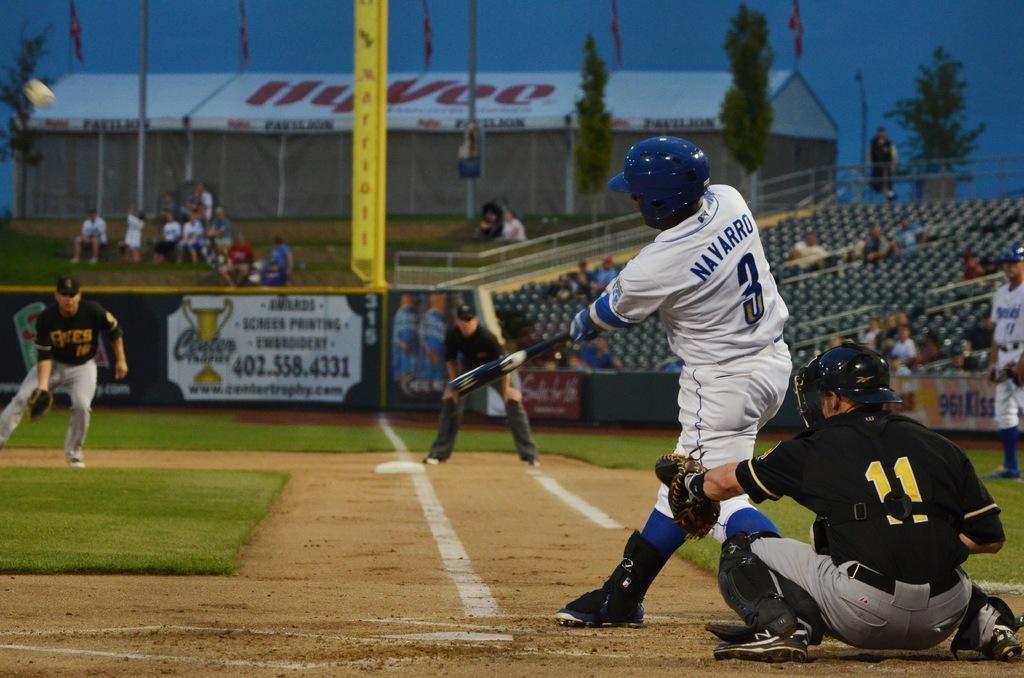Please provide a concise description of this image. In this image we can see the players. We can also see the people sitting. We can see the stands, house, trees, railing, hoardings and also the pole. We can also see the flags, sky and also the ground at the bottom. 